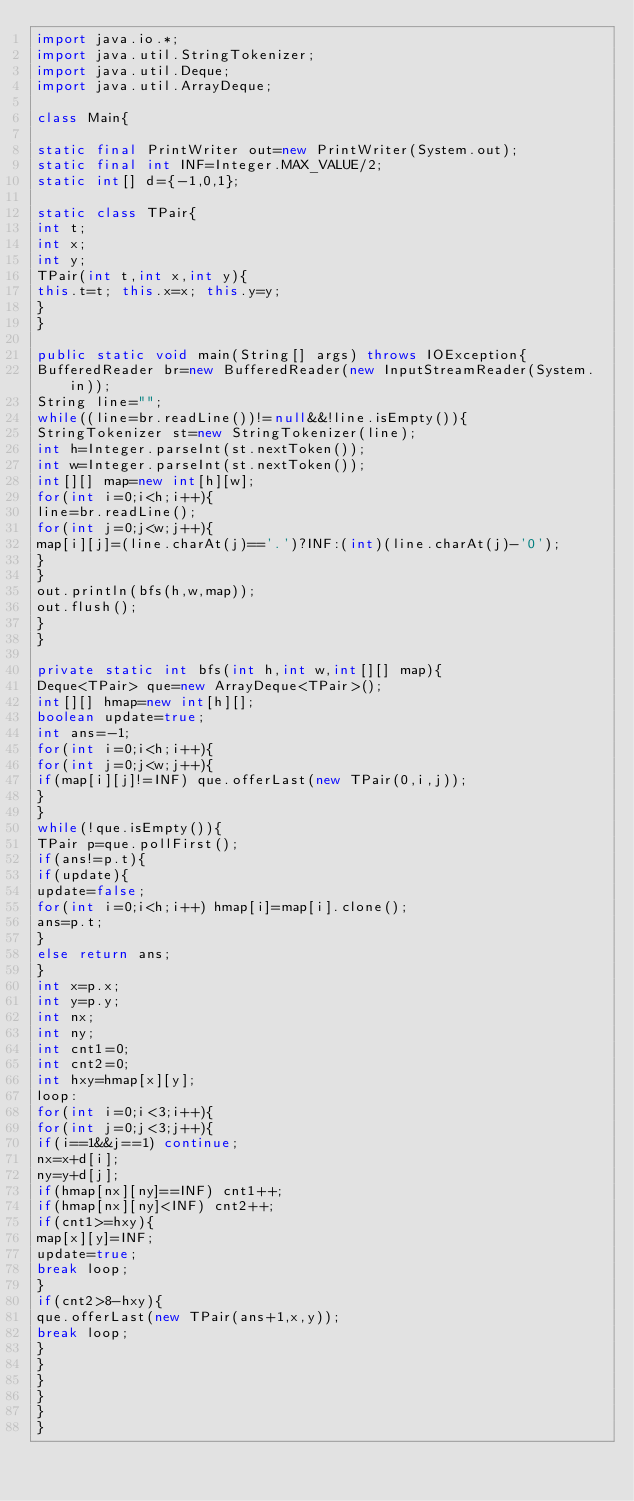Convert code to text. <code><loc_0><loc_0><loc_500><loc_500><_Java_>import java.io.*;
import java.util.StringTokenizer;
import java.util.Deque;
import java.util.ArrayDeque;

class Main{

static final PrintWriter out=new PrintWriter(System.out);
static final int INF=Integer.MAX_VALUE/2;
static int[] d={-1,0,1};

static class TPair{
int t;
int x;
int y;
TPair(int t,int x,int y){
this.t=t; this.x=x; this.y=y;
}
}

public static void main(String[] args) throws IOException{
BufferedReader br=new BufferedReader(new InputStreamReader(System.in));
String line="";
while((line=br.readLine())!=null&&!line.isEmpty()){
StringTokenizer st=new StringTokenizer(line);
int h=Integer.parseInt(st.nextToken());
int w=Integer.parseInt(st.nextToken());
int[][] map=new int[h][w];
for(int i=0;i<h;i++){
line=br.readLine();
for(int j=0;j<w;j++){
map[i][j]=(line.charAt(j)=='.')?INF:(int)(line.charAt(j)-'0');
}
}
out.println(bfs(h,w,map));
out.flush();
}
}

private static int bfs(int h,int w,int[][] map){
Deque<TPair> que=new ArrayDeque<TPair>();
int[][] hmap=new int[h][];
boolean update=true;
int ans=-1;
for(int i=0;i<h;i++){
for(int j=0;j<w;j++){
if(map[i][j]!=INF) que.offerLast(new TPair(0,i,j));
}
}
while(!que.isEmpty()){
TPair p=que.pollFirst();
if(ans!=p.t){
if(update){
update=false;
for(int i=0;i<h;i++) hmap[i]=map[i].clone();
ans=p.t;
}
else return ans;
}
int x=p.x;
int y=p.y;
int nx;
int ny;
int cnt1=0;
int cnt2=0;
int hxy=hmap[x][y];
loop:
for(int i=0;i<3;i++){
for(int j=0;j<3;j++){
if(i==1&&j==1) continue;
nx=x+d[i];
ny=y+d[j];
if(hmap[nx][ny]==INF) cnt1++;
if(hmap[nx][ny]<INF) cnt2++;
if(cnt1>=hxy){
map[x][y]=INF;
update=true;
break loop;
}
if(cnt2>8-hxy){
que.offerLast(new TPair(ans+1,x,y));
break loop;
}
}
}
}
}
}</code> 